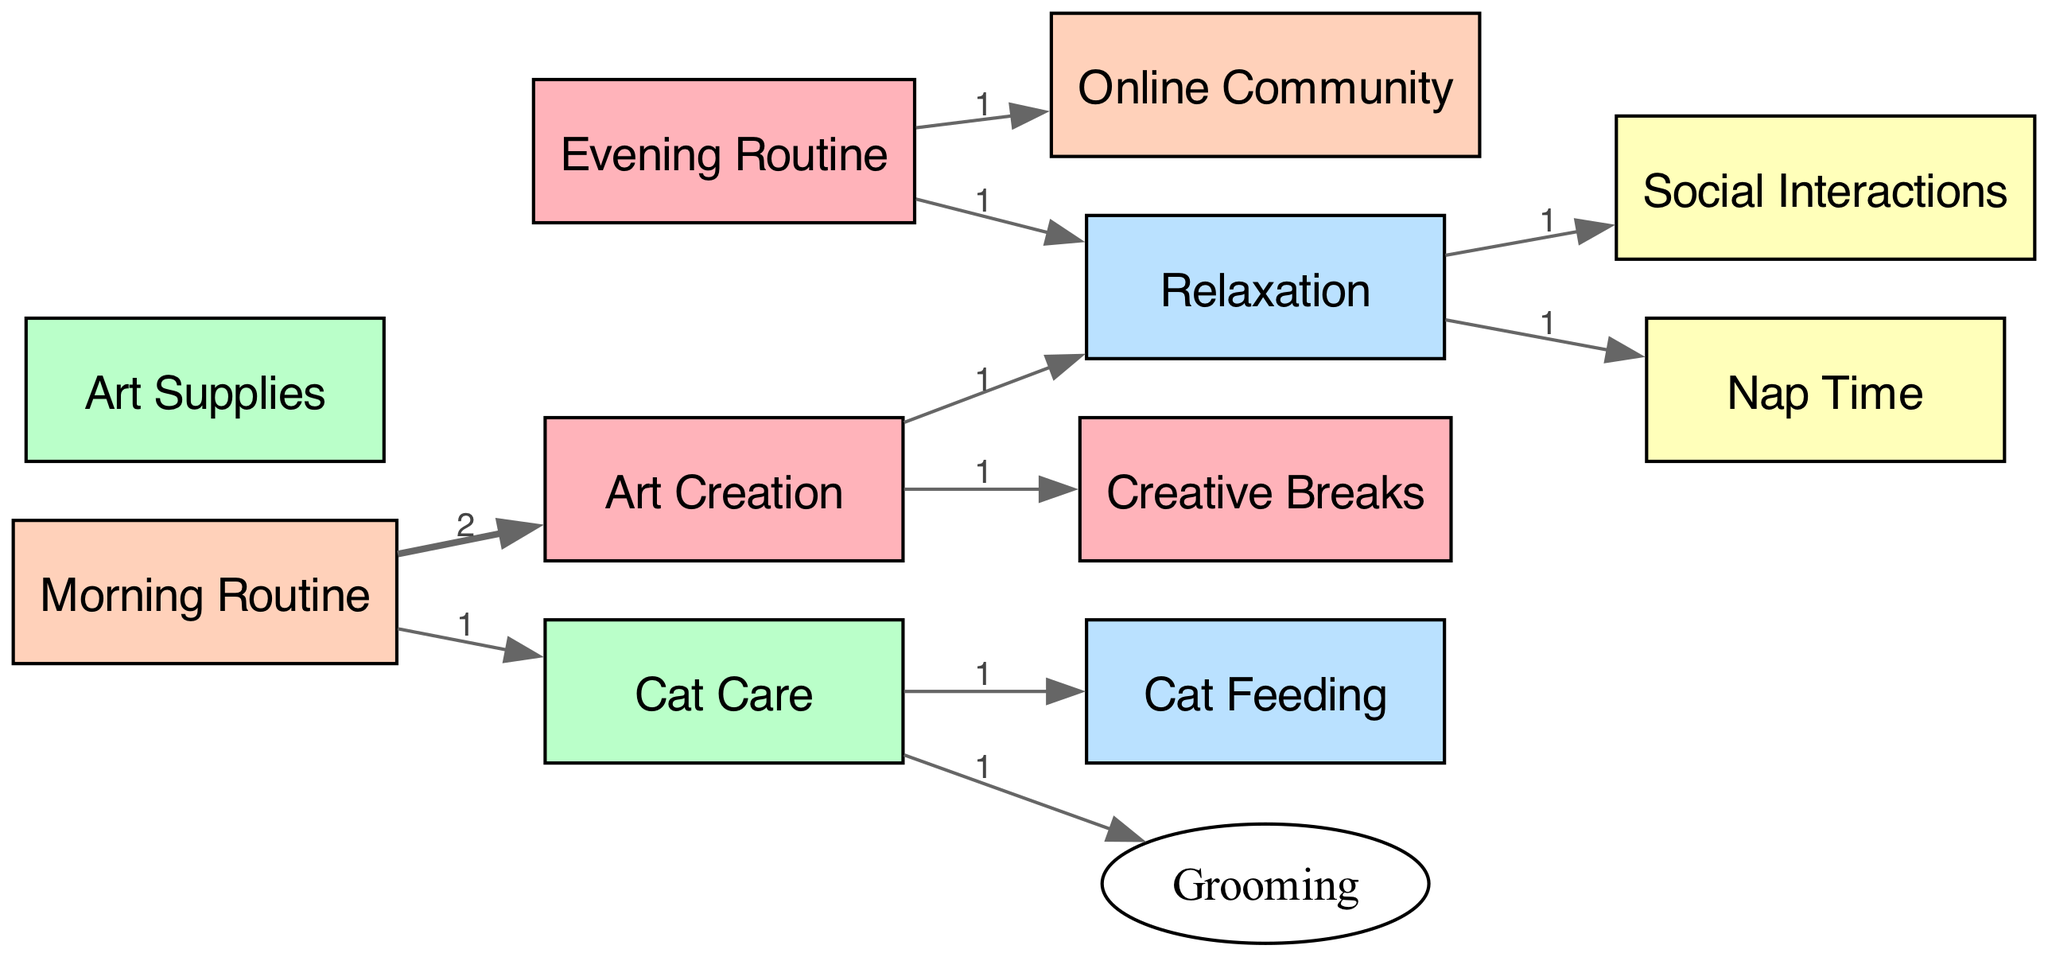What is the total number of nodes in the diagram? The diagram contains nodes such as "Art Creation," "Cat Care," "Relaxation," "Social Interactions," and others. By counting all unique nodes listed, we find there are 11 nodes in total.
Answer: 11 How many connections does "Relaxation" have? "Relaxation" connects to "Nap Time" and "Social Interactions," as indicated in the links section. Two unique connections can be counted here.
Answer: 2 What is the value of the link between "Morning Routine" and "Cat Care"? Looking at the links, the connection between "Morning Routine" and "Cat Care" has a value of 1, which indicates the amount of time spent from the "Morning Routine" to "Cat Care."
Answer: 1 Which node has the highest connection value? Reviewing the flow connections, the node "Art Creation" connects to "Creative Breaks" and "Relaxation," each with a value of 1. However, since they all connect with a value of 1, there is no single highest value; it is shared.
Answer: None What is the total value flowing from "Evening Routine"? The "Evening Routine" connects to "Online Community" and "Relaxation," both with a value of 1. The total value flowing from "Evening Routine" is the sum of these two values, resulting in 1 + 1 = 2.
Answer: 2 Which activity splits time between relaxation and social interactions? By examining the connections originating from "Relaxation," we see that it splits into "Nap Time" and "Social Interactions." "Relaxation" connects 1 time to each of them.
Answer: Relaxation How many nodes precede "Art Creation"? The node "Art Creation" is preceded by "Morning Routine," as it is the only direct flow leading to it. Therefore, there is 1 node preceding "Art Creation."
Answer: 1 What do the nodes "Cat Feeding" and "Grooming" have in common? Both "Cat Feeding" and "Grooming" are activities that stem from "Cat Care," indicating they are both parts of caring for the cat.
Answer: Cat Care Which nodes flow directly into "Relaxation"? From the diagram, "Art Creation" and "Evening Routine" are the two nodes that flow directly into "Relaxation." Therefore, there are two inflowing nodes.
Answer: 2 Does "Art Creation" directly influence "Social Interactions"? A review of the diagram connections shows there is no direct link from "Art Creation" to "Social Interactions," indicating they do not influence each other directly.
Answer: No 